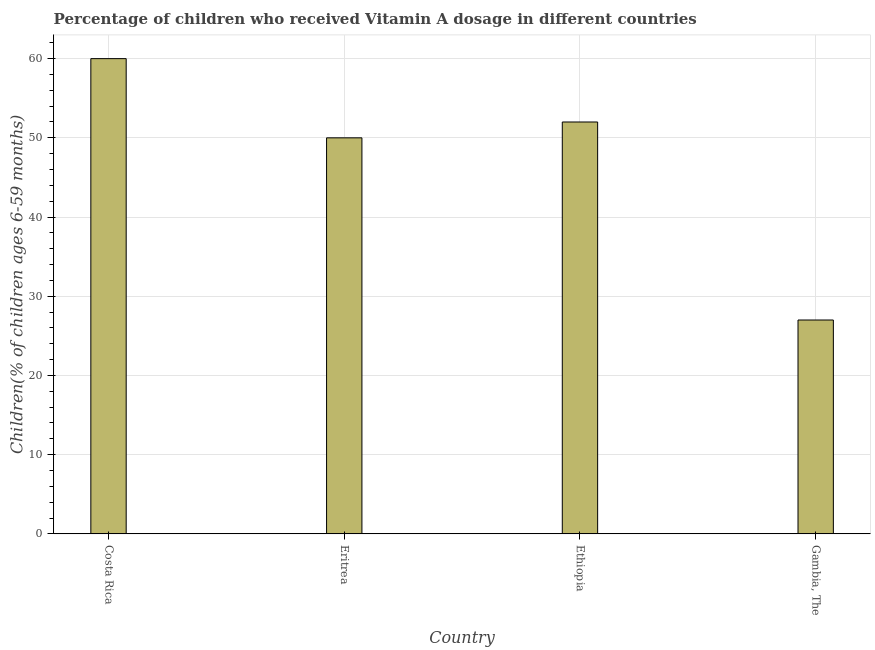Does the graph contain any zero values?
Offer a terse response. No. Does the graph contain grids?
Your answer should be very brief. Yes. What is the title of the graph?
Give a very brief answer. Percentage of children who received Vitamin A dosage in different countries. What is the label or title of the Y-axis?
Keep it short and to the point. Children(% of children ages 6-59 months). What is the vitamin a supplementation coverage rate in Ethiopia?
Keep it short and to the point. 52. Across all countries, what is the maximum vitamin a supplementation coverage rate?
Keep it short and to the point. 60. In which country was the vitamin a supplementation coverage rate minimum?
Your response must be concise. Gambia, The. What is the sum of the vitamin a supplementation coverage rate?
Provide a short and direct response. 189. What is the difference between the vitamin a supplementation coverage rate in Costa Rica and Gambia, The?
Your answer should be compact. 33. What is the average vitamin a supplementation coverage rate per country?
Give a very brief answer. 47.25. What is the median vitamin a supplementation coverage rate?
Ensure brevity in your answer.  51. In how many countries, is the vitamin a supplementation coverage rate greater than 6 %?
Ensure brevity in your answer.  4. Is the vitamin a supplementation coverage rate in Costa Rica less than that in Eritrea?
Offer a terse response. No. Is the difference between the vitamin a supplementation coverage rate in Costa Rica and Gambia, The greater than the difference between any two countries?
Offer a very short reply. Yes. What is the difference between the highest and the lowest vitamin a supplementation coverage rate?
Offer a very short reply. 33. In how many countries, is the vitamin a supplementation coverage rate greater than the average vitamin a supplementation coverage rate taken over all countries?
Your answer should be very brief. 3. How many bars are there?
Your response must be concise. 4. Are all the bars in the graph horizontal?
Your response must be concise. No. What is the difference between two consecutive major ticks on the Y-axis?
Offer a very short reply. 10. What is the Children(% of children ages 6-59 months) of Eritrea?
Your answer should be very brief. 50. What is the Children(% of children ages 6-59 months) in Ethiopia?
Your answer should be compact. 52. What is the Children(% of children ages 6-59 months) of Gambia, The?
Provide a succinct answer. 27. What is the difference between the Children(% of children ages 6-59 months) in Costa Rica and Eritrea?
Offer a terse response. 10. What is the difference between the Children(% of children ages 6-59 months) in Eritrea and Gambia, The?
Your answer should be very brief. 23. What is the ratio of the Children(% of children ages 6-59 months) in Costa Rica to that in Eritrea?
Your answer should be very brief. 1.2. What is the ratio of the Children(% of children ages 6-59 months) in Costa Rica to that in Ethiopia?
Offer a very short reply. 1.15. What is the ratio of the Children(% of children ages 6-59 months) in Costa Rica to that in Gambia, The?
Keep it short and to the point. 2.22. What is the ratio of the Children(% of children ages 6-59 months) in Eritrea to that in Ethiopia?
Keep it short and to the point. 0.96. What is the ratio of the Children(% of children ages 6-59 months) in Eritrea to that in Gambia, The?
Your response must be concise. 1.85. What is the ratio of the Children(% of children ages 6-59 months) in Ethiopia to that in Gambia, The?
Make the answer very short. 1.93. 